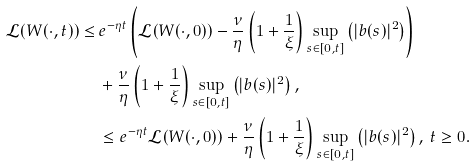Convert formula to latex. <formula><loc_0><loc_0><loc_500><loc_500>\mathcal { L } ( W ( \cdot , t ) ) \leq & \, e ^ { - \eta t } \left ( \mathcal { L } ( W ( \cdot , 0 ) ) - \frac { \nu } { \eta } \left ( 1 + \frac { 1 } { \xi } \right ) \sup _ { s \in [ 0 , t ] } \left ( | b ( s ) | ^ { 2 } \right ) \right ) \\ & \, + \frac { \nu } { \eta } \left ( 1 + \frac { 1 } { \xi } \right ) \sup _ { s \in [ 0 , t ] } \left ( | b ( s ) | ^ { 2 } \right ) , \\ & \, \leq e ^ { - \eta t } \mathcal { L } ( W ( \cdot , 0 ) ) + \frac { \nu } { \eta } \left ( 1 + \frac { 1 } { \xi } \right ) \sup _ { s \in [ 0 , t ] } \left ( | b ( s ) | ^ { 2 } \right ) , \, t \geq 0 .</formula> 